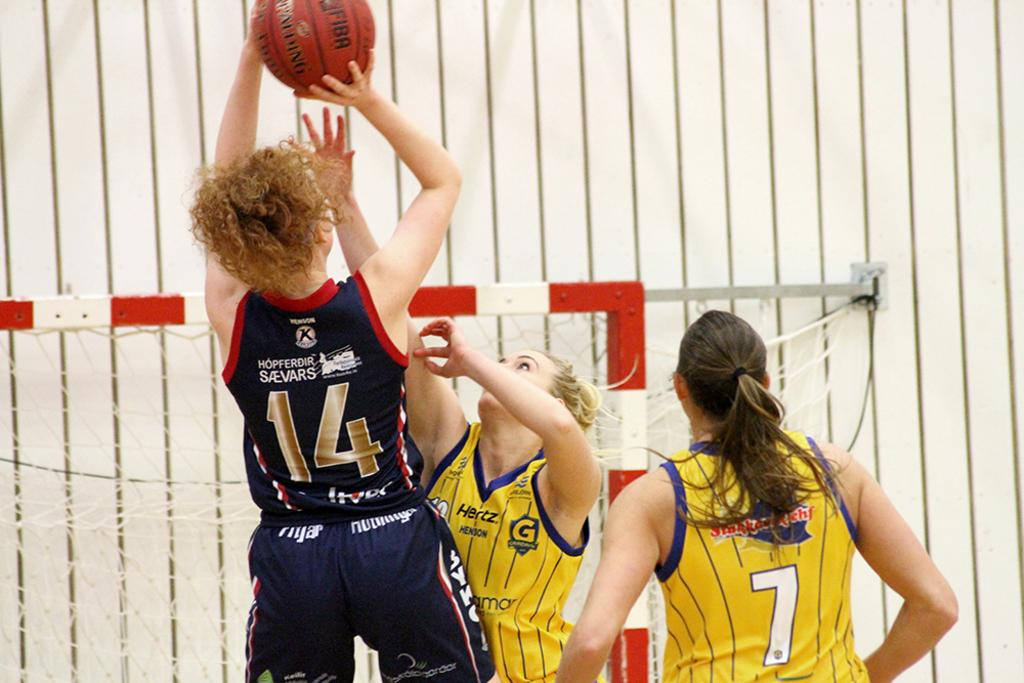<image>
Create a compact narrative representing the image presented. A woman playing basketball with a blue jersey with the number 14 on it, next to 2 other players in yellow jerseys. 